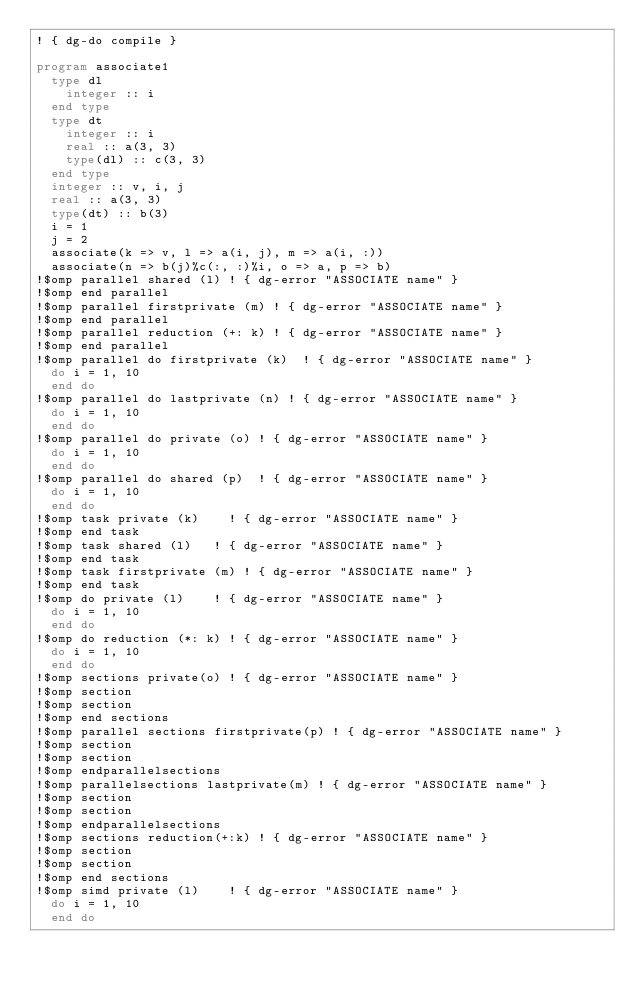<code> <loc_0><loc_0><loc_500><loc_500><_FORTRAN_>! { dg-do compile }

program associate1
  type dl
    integer :: i
  end type
  type dt
    integer :: i
    real :: a(3, 3)
    type(dl) :: c(3, 3)
  end type
  integer :: v, i, j
  real :: a(3, 3)
  type(dt) :: b(3)
  i = 1
  j = 2
  associate(k => v, l => a(i, j), m => a(i, :))
  associate(n => b(j)%c(:, :)%i, o => a, p => b)
!$omp parallel shared (l)	! { dg-error "ASSOCIATE name" }
!$omp end parallel
!$omp parallel firstprivate (m)	! { dg-error "ASSOCIATE name" }
!$omp end parallel
!$omp parallel reduction (+: k)	! { dg-error "ASSOCIATE name" }
!$omp end parallel
!$omp parallel do firstprivate (k)	! { dg-error "ASSOCIATE name" }
  do i = 1, 10
  end do
!$omp parallel do lastprivate (n)	! { dg-error "ASSOCIATE name" }
  do i = 1, 10
  end do
!$omp parallel do private (o)	! { dg-error "ASSOCIATE name" }
  do i = 1, 10
  end do
!$omp parallel do shared (p)	! { dg-error "ASSOCIATE name" }
  do i = 1, 10
  end do
!$omp task private (k)		! { dg-error "ASSOCIATE name" }
!$omp end task
!$omp task shared (l)		! { dg-error "ASSOCIATE name" }
!$omp end task
!$omp task firstprivate (m)	! { dg-error "ASSOCIATE name" }
!$omp end task
!$omp do private (l)		! { dg-error "ASSOCIATE name" }
  do i = 1, 10
  end do
!$omp do reduction (*: k)	! { dg-error "ASSOCIATE name" }
  do i = 1, 10
  end do
!$omp sections private(o)	! { dg-error "ASSOCIATE name" }
!$omp section
!$omp section
!$omp end sections
!$omp parallel sections firstprivate(p)	! { dg-error "ASSOCIATE name" }
!$omp section
!$omp section
!$omp endparallelsections
!$omp parallelsections lastprivate(m)	! { dg-error "ASSOCIATE name" }
!$omp section
!$omp section
!$omp endparallelsections
!$omp sections reduction(+:k)	! { dg-error "ASSOCIATE name" }
!$omp section
!$omp section
!$omp end sections
!$omp simd private (l)		! { dg-error "ASSOCIATE name" }
  do i = 1, 10
  end do</code> 